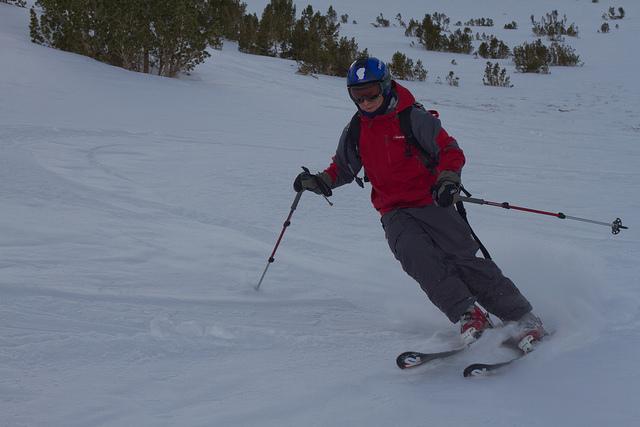Is the skier in motion or posing?
Give a very brief answer. In motion. Is the person snowboarding?
Concise answer only. No. Are his knees together?
Write a very short answer. Yes. Is this skier wearing a helmet?
Write a very short answer. Yes. What color of jacket is this person wearing?
Concise answer only. Red. What color is the inside of the hood?
Concise answer only. Red. How many poles are touching the snow?
Write a very short answer. 1. Is the person having fun?
Keep it brief. Yes. Is the person using HEAD skis?
Quick response, please. No. How many people are in this picture?
Keep it brief. 1. 